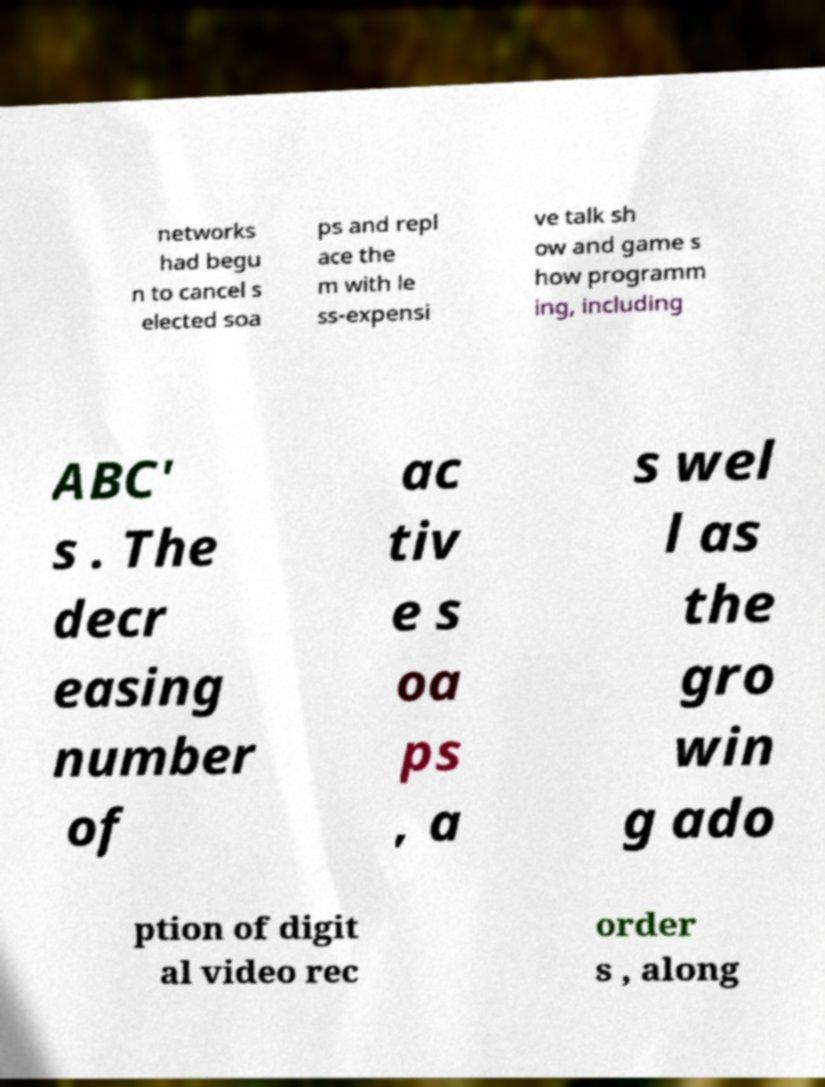I need the written content from this picture converted into text. Can you do that? networks had begu n to cancel s elected soa ps and repl ace the m with le ss-expensi ve talk sh ow and game s how programm ing, including ABC' s . The decr easing number of ac tiv e s oa ps , a s wel l as the gro win g ado ption of digit al video rec order s , along 